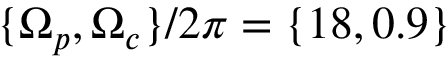<formula> <loc_0><loc_0><loc_500><loc_500>\{ \Omega _ { p } , \Omega _ { c } \} / 2 \pi = \{ 1 8 , 0 . 9 \}</formula> 